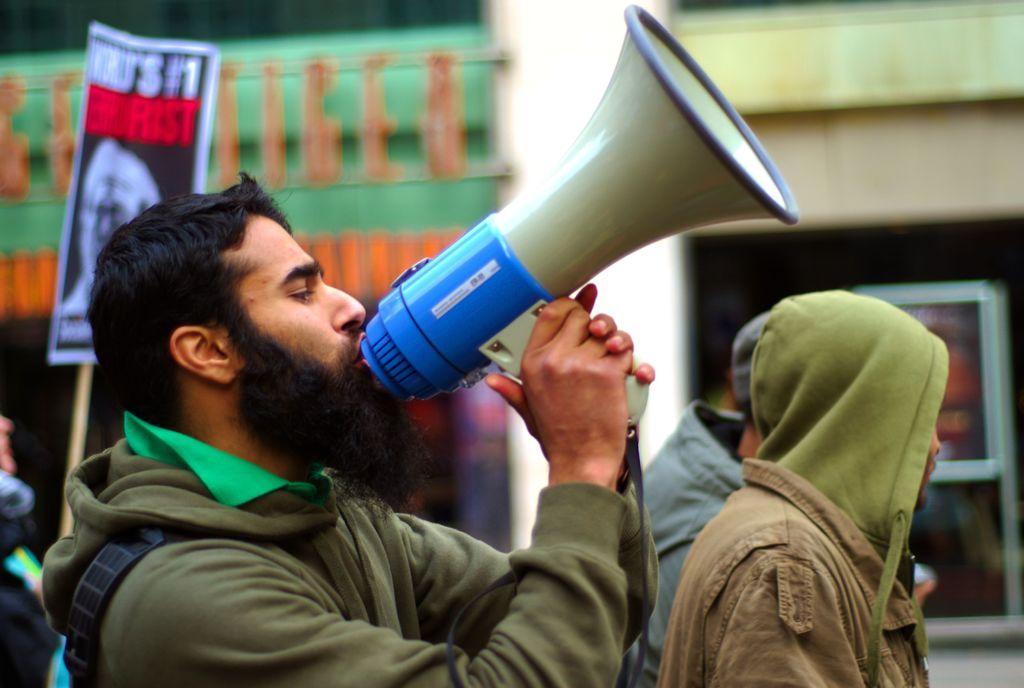Could you give a brief overview of what you see in this image? In this image we can see a person holding a megaphone. On the backside we can see some people. In that a person is holding a board with a stick. 